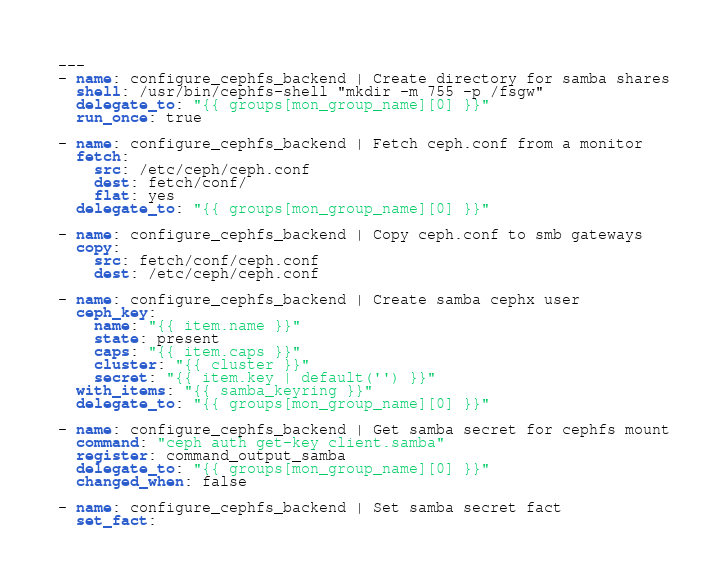<code> <loc_0><loc_0><loc_500><loc_500><_YAML_>---
- name: configure_cephfs_backend | Create directory for samba shares
  shell: /usr/bin/cephfs-shell "mkdir -m 755 -p /fsgw"
  delegate_to: "{{ groups[mon_group_name][0] }}"
  run_once: true

- name: configure_cephfs_backend | Fetch ceph.conf from a monitor
  fetch:
    src: /etc/ceph/ceph.conf
    dest: fetch/conf/
    flat: yes
  delegate_to: "{{ groups[mon_group_name][0] }}"

- name: configure_cephfs_backend | Copy ceph.conf to smb gateways
  copy:
    src: fetch/conf/ceph.conf
    dest: /etc/ceph/ceph.conf

- name: configure_cephfs_backend | Create samba cephx user
  ceph_key:
    name: "{{ item.name }}"
    state: present
    caps: "{{ item.caps }}"
    cluster: "{{ cluster }}"
    secret: "{{ item.key | default('') }}"
  with_items: "{{ samba_keyring }}"
  delegate_to: "{{ groups[mon_group_name][0] }}"

- name: configure_cephfs_backend | Get samba secret for cephfs mount
  command: "ceph auth get-key client.samba"
  register: command_output_samba
  delegate_to: "{{ groups[mon_group_name][0] }}"
  changed_when: false

- name: configure_cephfs_backend | Set samba secret fact
  set_fact:</code> 